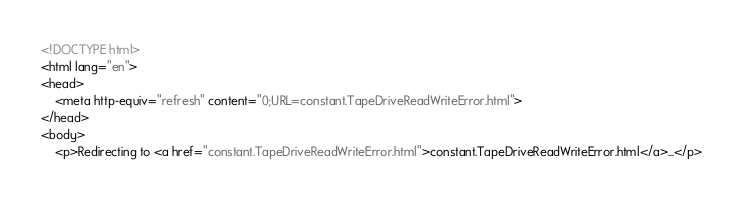Convert code to text. <code><loc_0><loc_0><loc_500><loc_500><_HTML_><!DOCTYPE html>
<html lang="en">
<head>
    <meta http-equiv="refresh" content="0;URL=constant.TapeDriveReadWriteError.html">
</head>
<body>
    <p>Redirecting to <a href="constant.TapeDriveReadWriteError.html">constant.TapeDriveReadWriteError.html</a>...</p></code> 